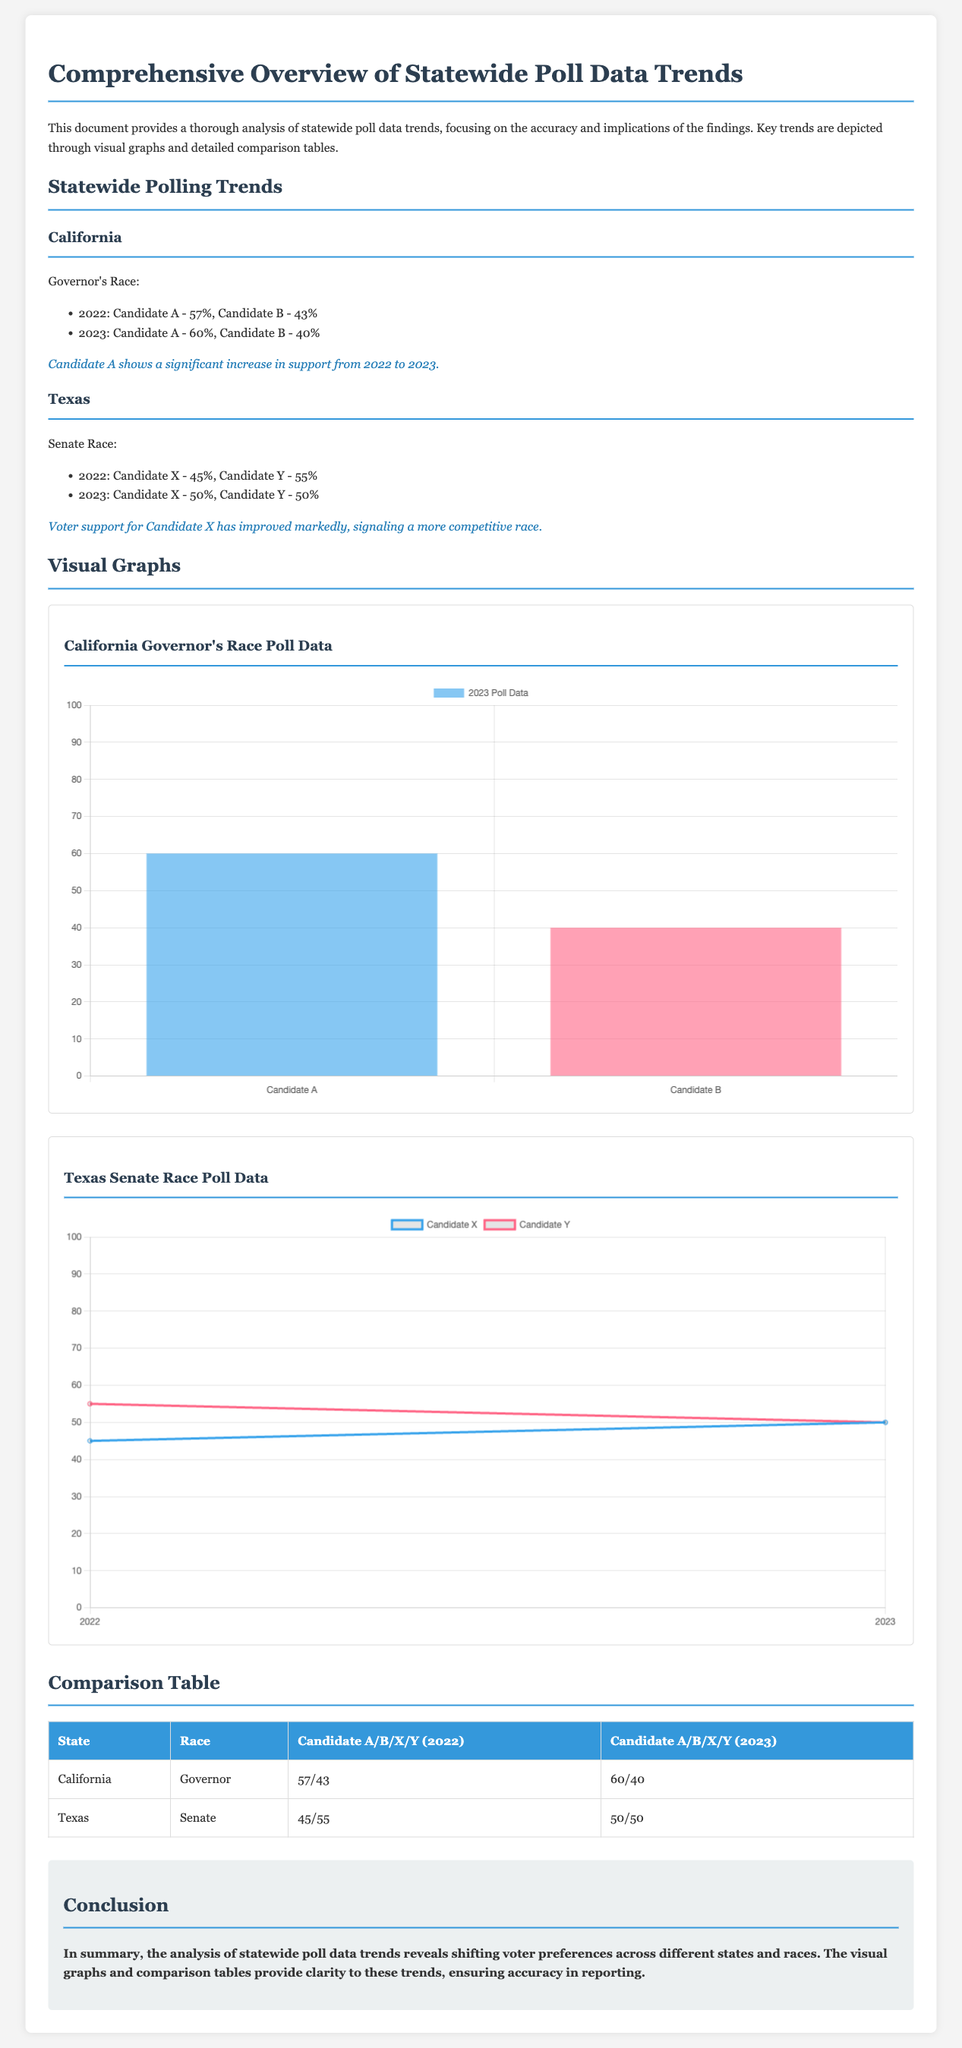What percentage of support did Candidate A receive in 2023 in California? The document states that Candidate A received 60% support in California in 2023.
Answer: 60% What is the percentage change for Candidate X from 2022 to 2023 in Texas? Candidate X's support increased from 45% in 2022 to 50% in 2023, showing a 5% increase.
Answer: 5% What is the support percentage for Candidate B in California in 2022? According to the document, Candidate B received 43% support in California in 2022.
Answer: 43% Which state showed a tie in the 2023 polling data? The document indicates that Texas showed a tie with both candidates receiving 50% support in 2023.
Answer: Texas What type of race is reported for Candidate A in California? The document mentions that Candidate A is in the Governor's race in California.
Answer: Governor's Race What color is used for Candidate X's line in the Texas chart? The document states that Candidate X's line is colored in rgba(54, 162, 235, 1).
Answer: Blue How many candidates are represented in the comparison table for Texas? The comparison table in the document shows two candidates represented for Texas (Candidate X and Candidate Y).
Answer: Two What is the focus of the document? The document focuses on analyzing statewide poll data trends and their implications.
Answer: Poll data trends 